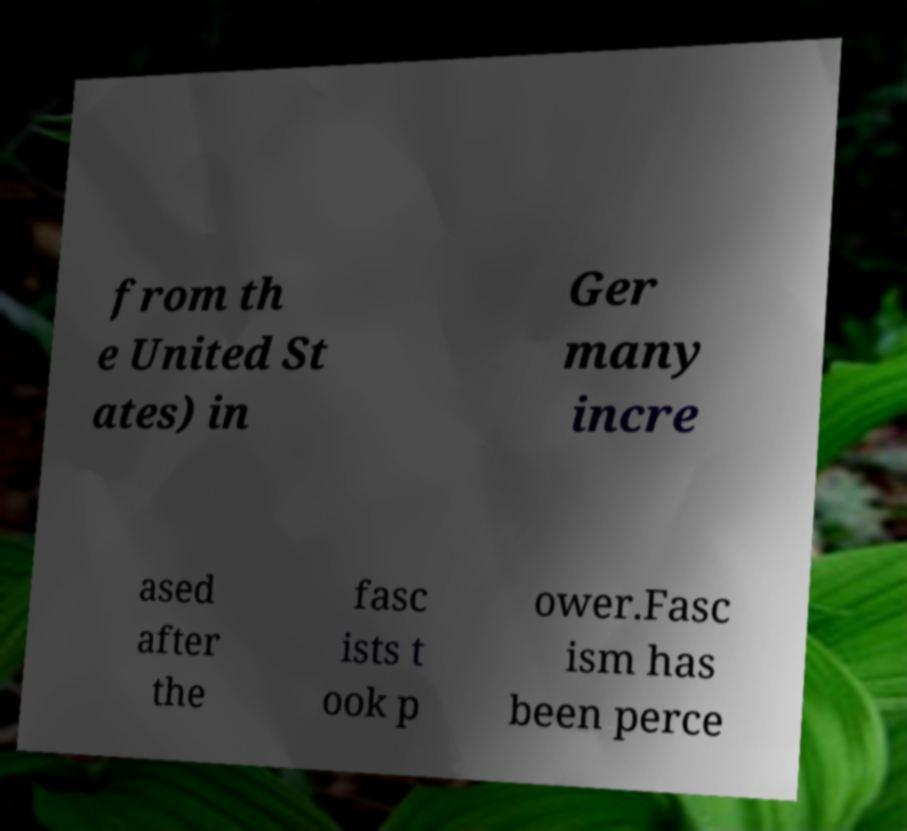I need the written content from this picture converted into text. Can you do that? from th e United St ates) in Ger many incre ased after the fasc ists t ook p ower.Fasc ism has been perce 